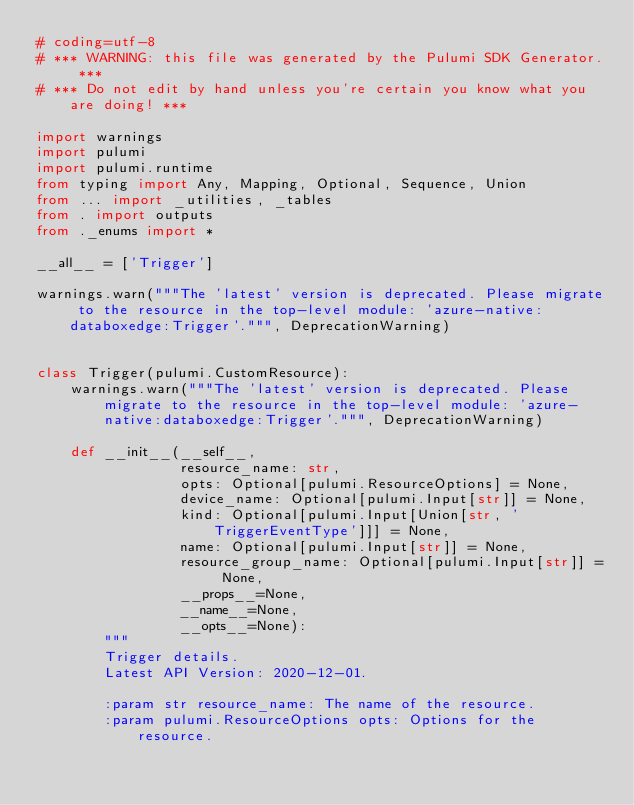Convert code to text. <code><loc_0><loc_0><loc_500><loc_500><_Python_># coding=utf-8
# *** WARNING: this file was generated by the Pulumi SDK Generator. ***
# *** Do not edit by hand unless you're certain you know what you are doing! ***

import warnings
import pulumi
import pulumi.runtime
from typing import Any, Mapping, Optional, Sequence, Union
from ... import _utilities, _tables
from . import outputs
from ._enums import *

__all__ = ['Trigger']

warnings.warn("""The 'latest' version is deprecated. Please migrate to the resource in the top-level module: 'azure-native:databoxedge:Trigger'.""", DeprecationWarning)


class Trigger(pulumi.CustomResource):
    warnings.warn("""The 'latest' version is deprecated. Please migrate to the resource in the top-level module: 'azure-native:databoxedge:Trigger'.""", DeprecationWarning)

    def __init__(__self__,
                 resource_name: str,
                 opts: Optional[pulumi.ResourceOptions] = None,
                 device_name: Optional[pulumi.Input[str]] = None,
                 kind: Optional[pulumi.Input[Union[str, 'TriggerEventType']]] = None,
                 name: Optional[pulumi.Input[str]] = None,
                 resource_group_name: Optional[pulumi.Input[str]] = None,
                 __props__=None,
                 __name__=None,
                 __opts__=None):
        """
        Trigger details.
        Latest API Version: 2020-12-01.

        :param str resource_name: The name of the resource.
        :param pulumi.ResourceOptions opts: Options for the resource.</code> 